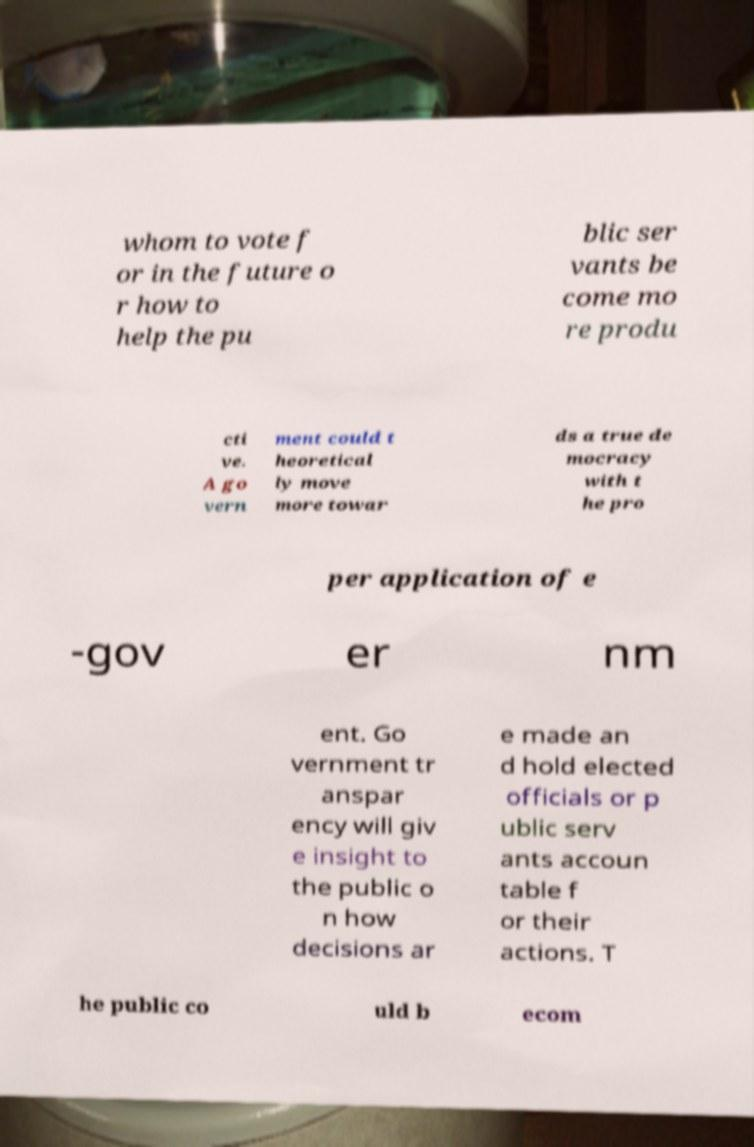Please identify and transcribe the text found in this image. whom to vote f or in the future o r how to help the pu blic ser vants be come mo re produ cti ve. A go vern ment could t heoretical ly move more towar ds a true de mocracy with t he pro per application of e -gov er nm ent. Go vernment tr anspar ency will giv e insight to the public o n how decisions ar e made an d hold elected officials or p ublic serv ants accoun table f or their actions. T he public co uld b ecom 